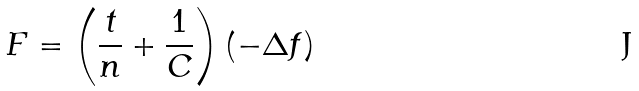<formula> <loc_0><loc_0><loc_500><loc_500>F = \left ( \frac { t } { n } + \frac { 1 } { C } \right ) \left ( - \Delta f \right )</formula> 